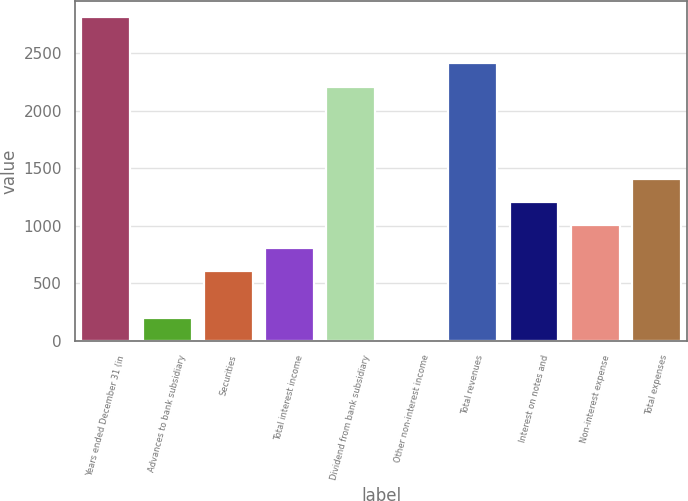<chart> <loc_0><loc_0><loc_500><loc_500><bar_chart><fcel>Years ended December 31 (in<fcel>Advances to bank subsidiary<fcel>Securities<fcel>Total interest income<fcel>Dividend from bank subsidiary<fcel>Other non-interest income<fcel>Total revenues<fcel>Interest on notes and<fcel>Non-interest expense<fcel>Total expenses<nl><fcel>2815.28<fcel>201.37<fcel>603.51<fcel>804.58<fcel>2212.07<fcel>0.3<fcel>2413.14<fcel>1206.72<fcel>1005.65<fcel>1407.79<nl></chart> 